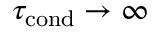<formula> <loc_0><loc_0><loc_500><loc_500>\tau _ { c o n d } \rightarrow \infty</formula> 